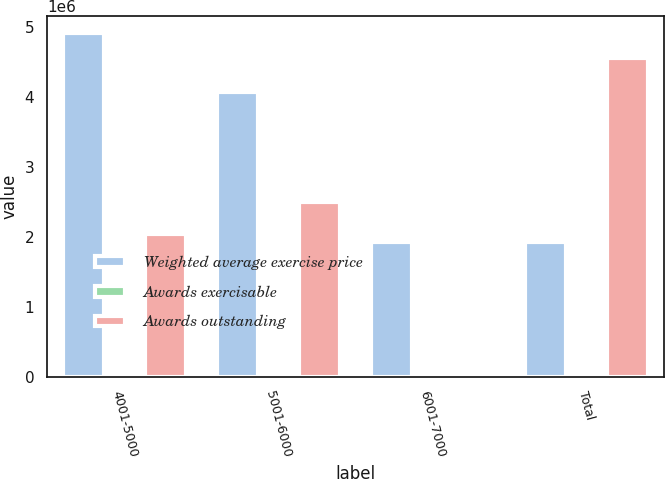<chart> <loc_0><loc_0><loc_500><loc_500><stacked_bar_chart><ecel><fcel>4001-5000<fcel>5001-6000<fcel>6001-7000<fcel>Total<nl><fcel>Weighted average exercise price<fcel>4.91796e+06<fcel>4.07306e+06<fcel>1.93246e+06<fcel>1.93246e+06<nl><fcel>Awards exercisable<fcel>46.1<fcel>52.74<fcel>64.15<fcel>49.68<nl><fcel>Awards outstanding<fcel>2.04811e+06<fcel>2.49713e+06<fcel>15332<fcel>4.56717e+06<nl></chart> 